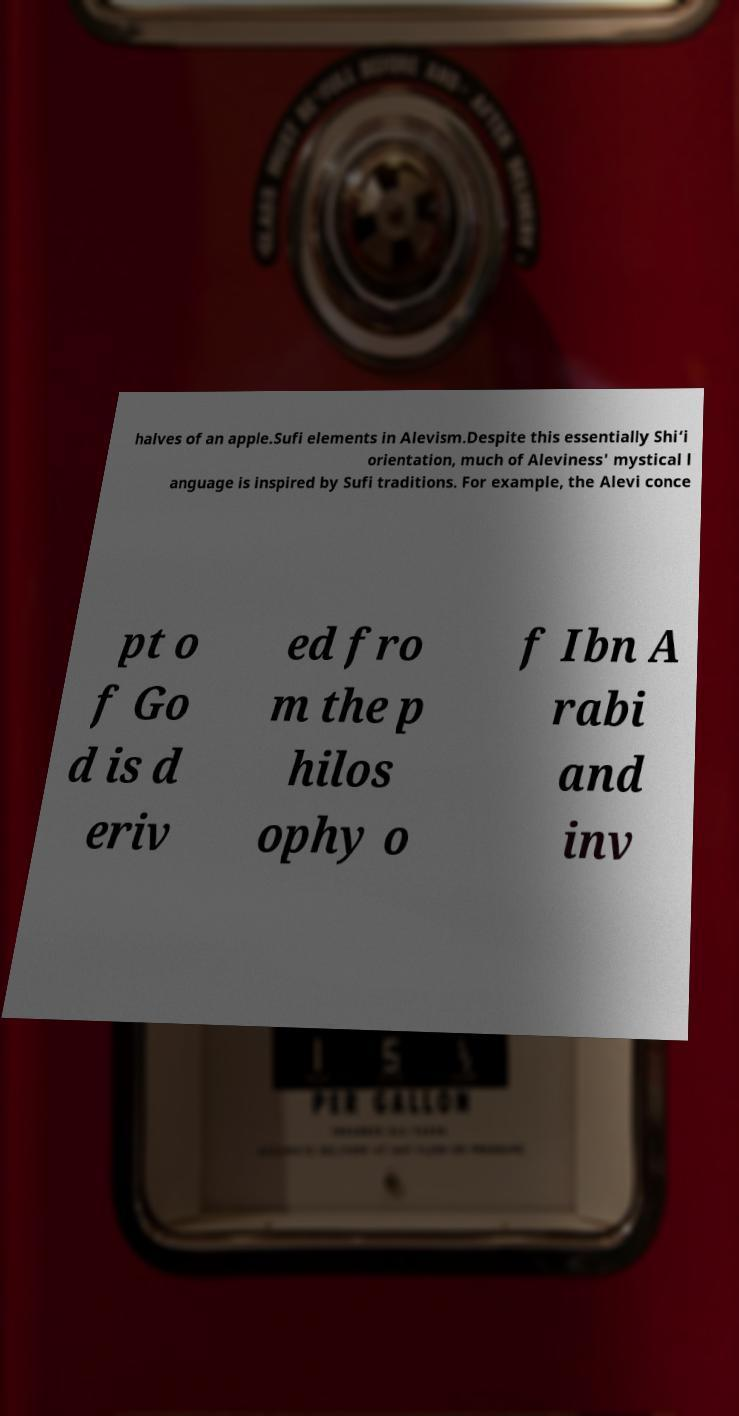What messages or text are displayed in this image? I need them in a readable, typed format. halves of an apple.Sufi elements in Alevism.Despite this essentially Shi‘i orientation, much of Aleviness' mystical l anguage is inspired by Sufi traditions. For example, the Alevi conce pt o f Go d is d eriv ed fro m the p hilos ophy o f Ibn A rabi and inv 